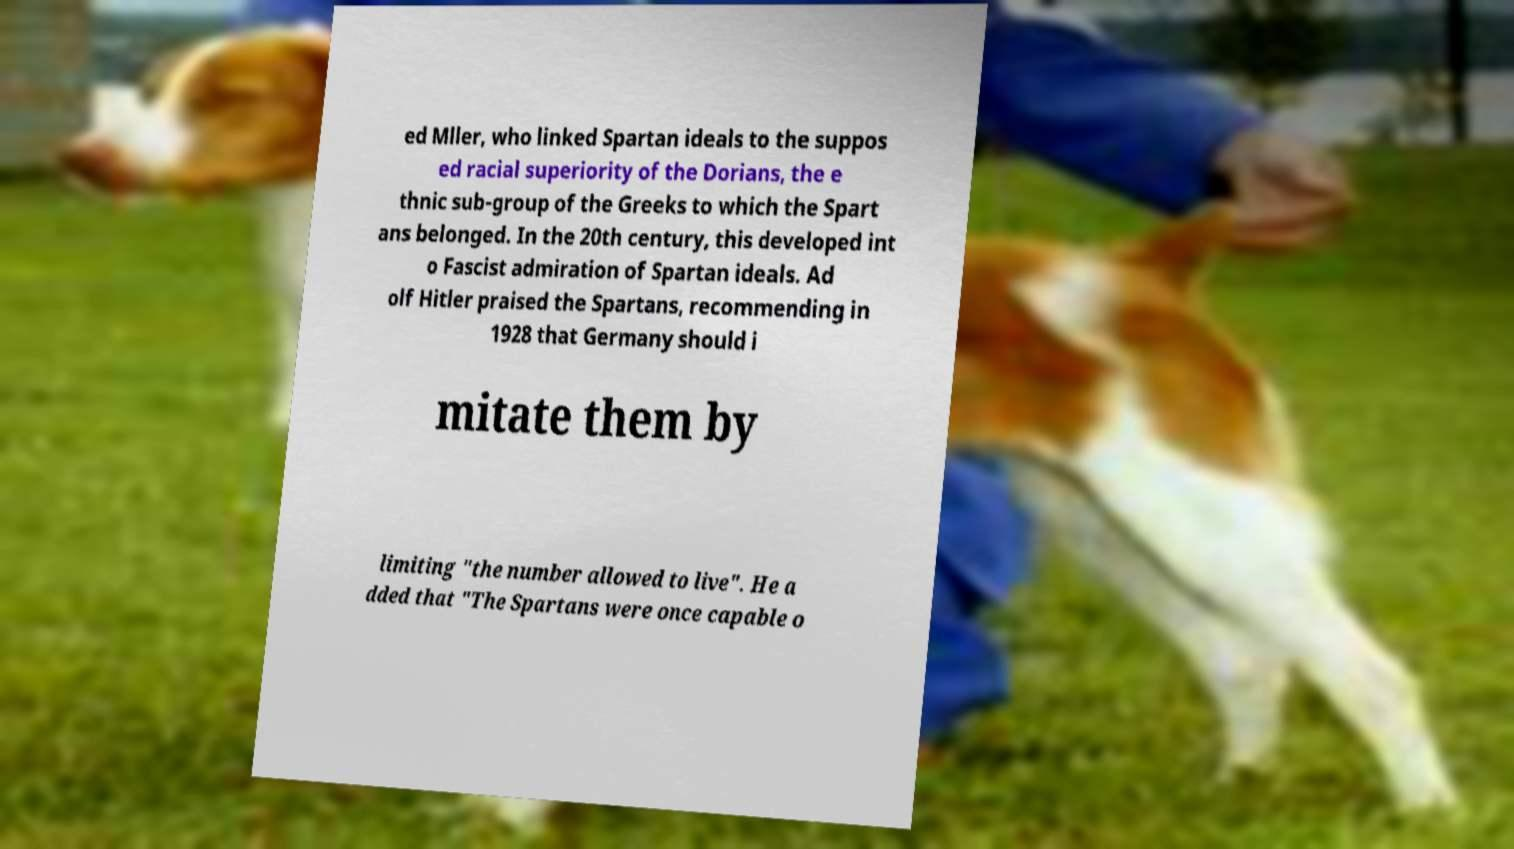Could you extract and type out the text from this image? ed Mller, who linked Spartan ideals to the suppos ed racial superiority of the Dorians, the e thnic sub-group of the Greeks to which the Spart ans belonged. In the 20th century, this developed int o Fascist admiration of Spartan ideals. Ad olf Hitler praised the Spartans, recommending in 1928 that Germany should i mitate them by limiting "the number allowed to live". He a dded that "The Spartans were once capable o 